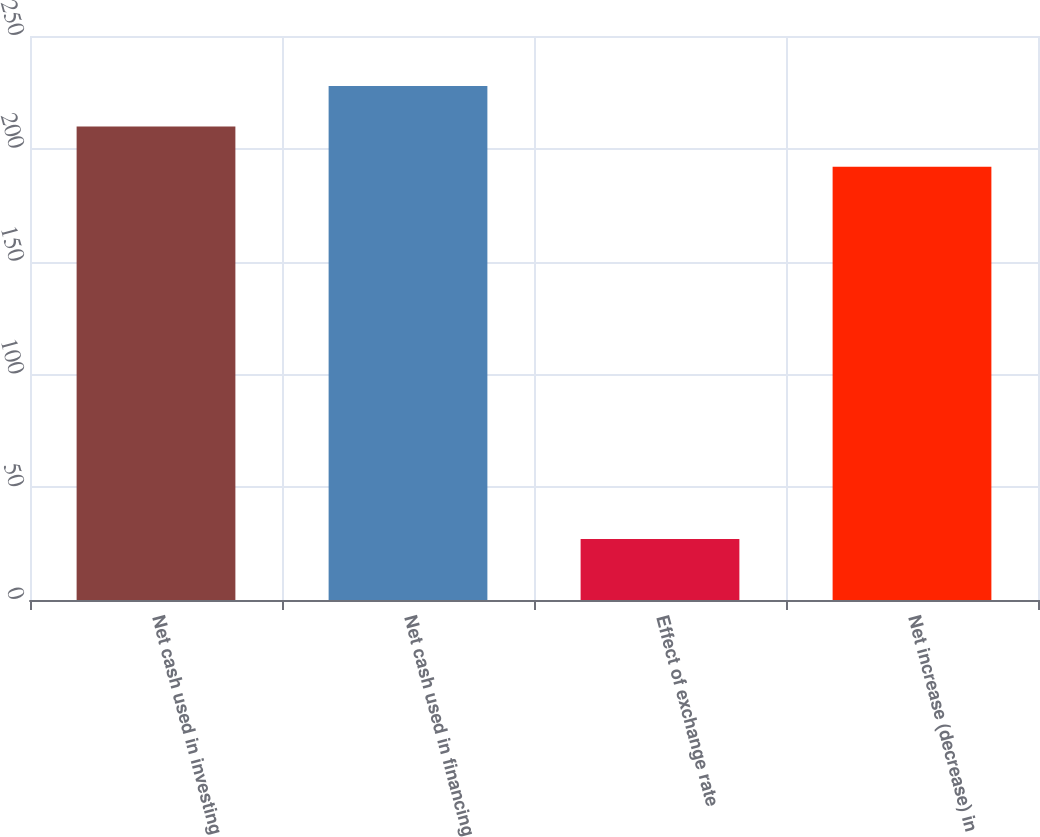Convert chart to OTSL. <chart><loc_0><loc_0><loc_500><loc_500><bar_chart><fcel>Net cash used in investing<fcel>Net cash used in financing<fcel>Effect of exchange rate<fcel>Net increase (decrease) in<nl><fcel>209.92<fcel>227.84<fcel>27<fcel>192<nl></chart> 